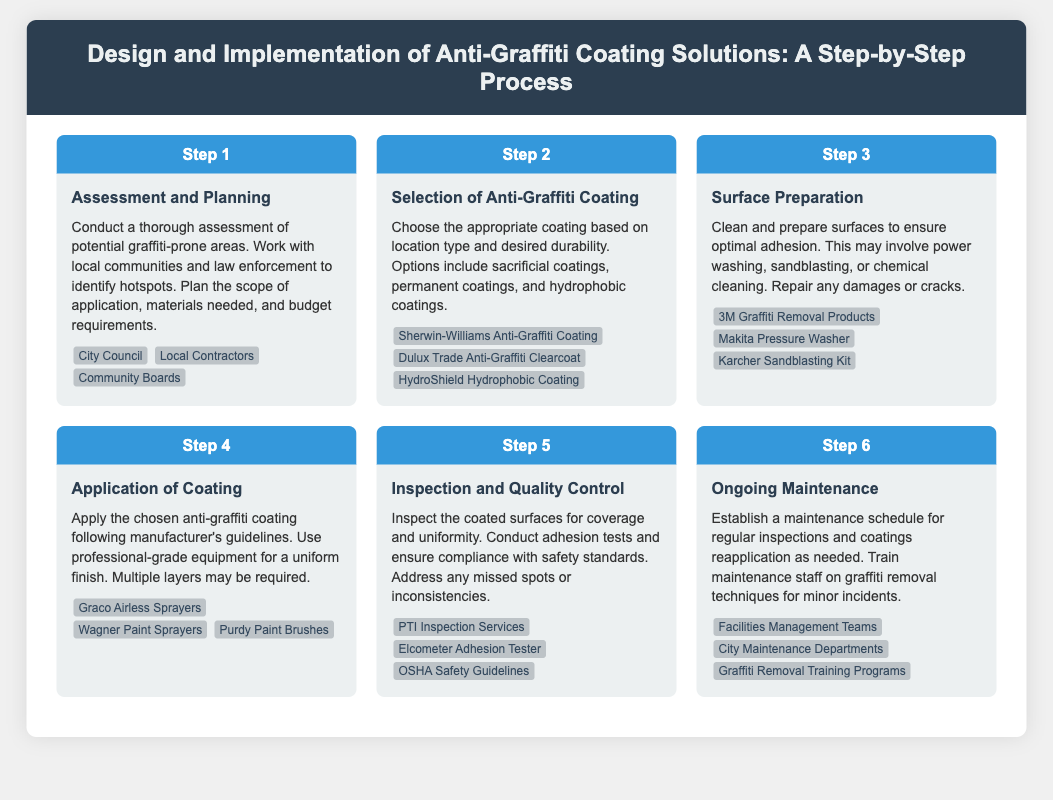What is the first step in the anti-graffiti coating process? The first step in the process is "Assessment and Planning."
Answer: Assessment and Planning What type of coating is suitable for high durability? The document mentions that "permanent coatings" are ideal for high durability.
Answer: Permanent coatings Which companies offer anti-graffiti coatings? The document lists several companies, including "Sherwin-Williams Anti-Graffiti Coating" and "Dulux Trade Anti-Graffiti Clearcoat."
Answer: Sherwin-Williams Anti-Graffiti Coating, Dulux Trade Anti-Graffiti Clearcoat What equipment is recommended for surface preparation? The document suggests using "Makita Pressure Washer" and "Karcher Sandblasting Kit" for surface preparation.
Answer: Makita Pressure Washer, Karcher Sandblasting Kit How many steps are in the anti-graffiti coating process? The document outlines a total of six steps in the process.
Answer: Six steps What is required during the inspection and quality control step? The step includes "conduct adhesion tests" and ensuring "compliance with safety standards."
Answer: Conduct adhesion tests, ensure compliance with safety standards What is the purpose of ongoing maintenance? Ongoing maintenance involves "regular inspections and coatings reapplication as needed."
Answer: Regular inspections and coatings reapplication Who should be trained on graffiti removal techniques? The document states that "maintenance staff" should be trained on graffiti removal techniques.
Answer: Maintenance staff 